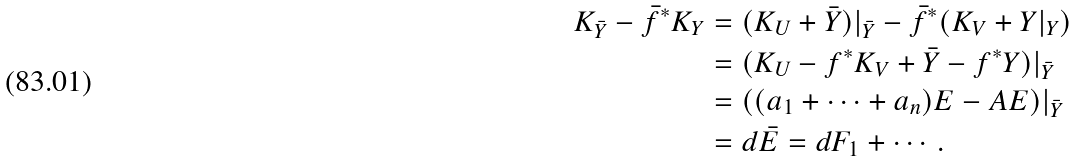Convert formula to latex. <formula><loc_0><loc_0><loc_500><loc_500>K _ { \bar { Y } } - \bar { f } ^ { * } K _ { Y } & = ( K _ { U } + \bar { Y } ) | _ { \bar { Y } } - \bar { f } ^ { * } ( K _ { V } + Y | _ { Y } ) \\ & = ( K _ { U } - f ^ { * } K _ { V } + \bar { Y } - f ^ { * } Y ) | _ { \bar { Y } } \\ & = ( ( a _ { 1 } + \cdots + a _ { n } ) E - A E ) | _ { \bar { Y } } \\ & = d \bar { E } = d F _ { 1 } + \cdots .</formula> 